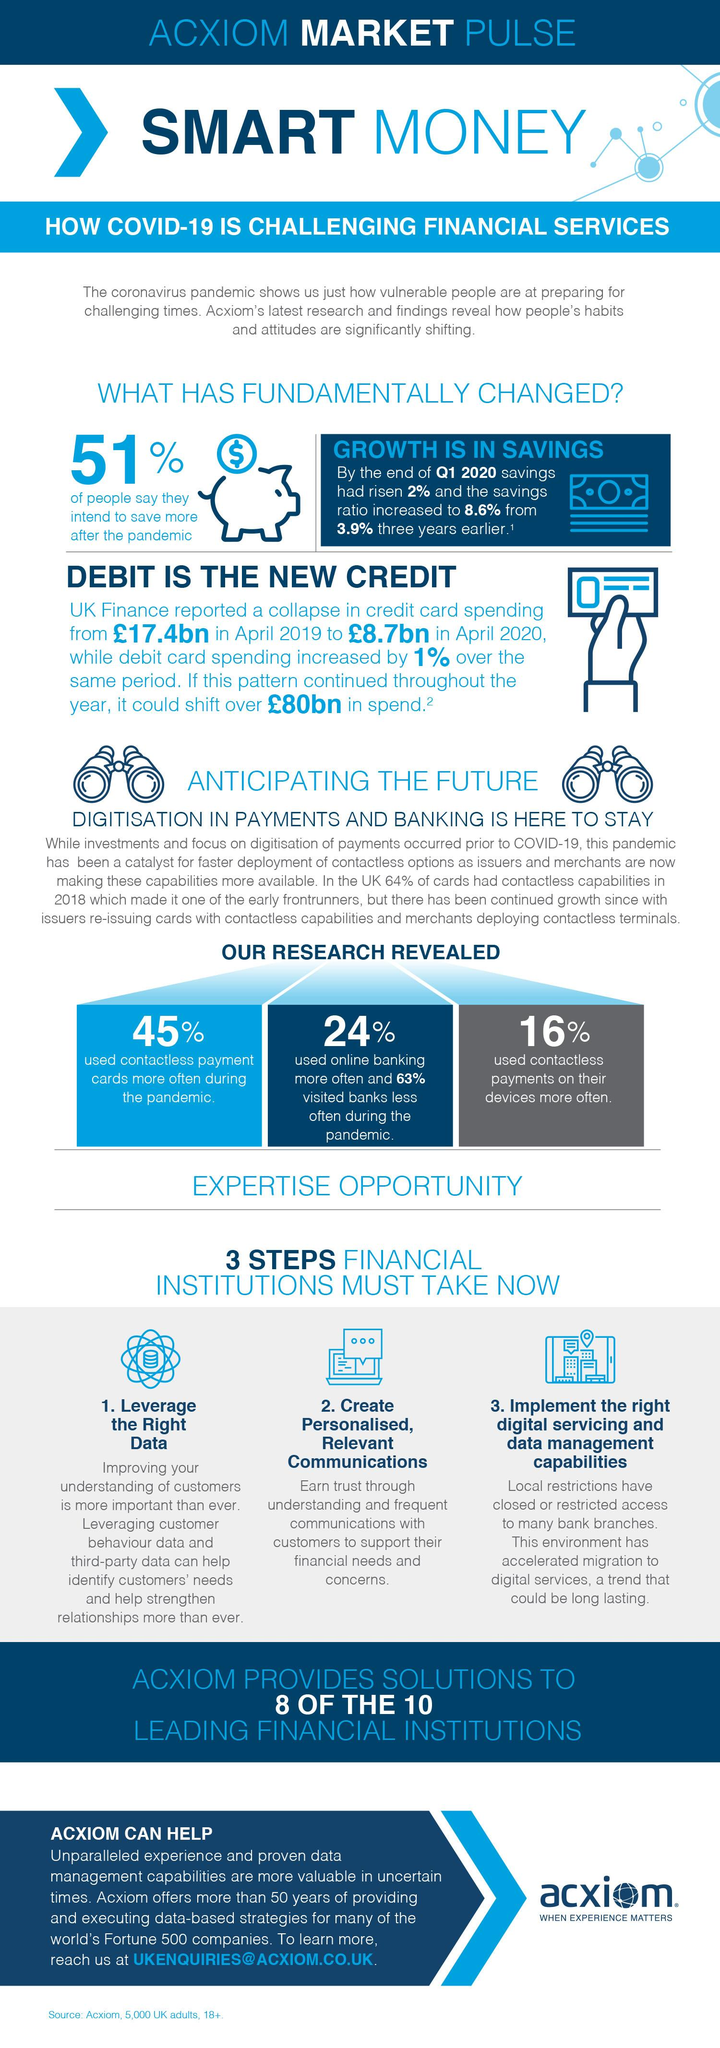List a handful of essential elements in this visual. During the pandemic, 45% of people used contactless payment cards. Sixty-three percent of the individuals surveyed reported reducing their visits to banks. According to the survey, 51% of people plan to save more after the pandemic, indicating that many individuals are taking the opportunity to improve their financial situation. 